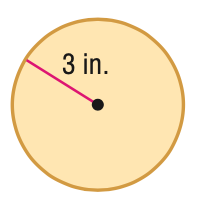Answer the mathemtical geometry problem and directly provide the correct option letter.
Question: Find the circumference of the figure. Round to the nearest tenth.
Choices: A: 9.4 B: 18.8 C: 28.3 D: 37.7 B 